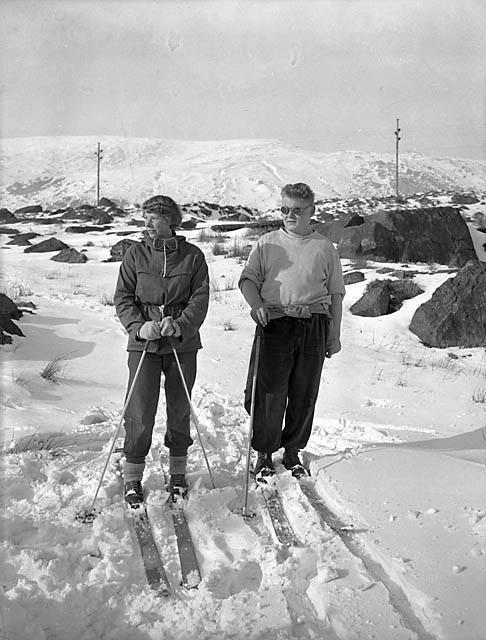How many people can you see?
Give a very brief answer. 2. How many people are on the elephant on the right?
Give a very brief answer. 0. 